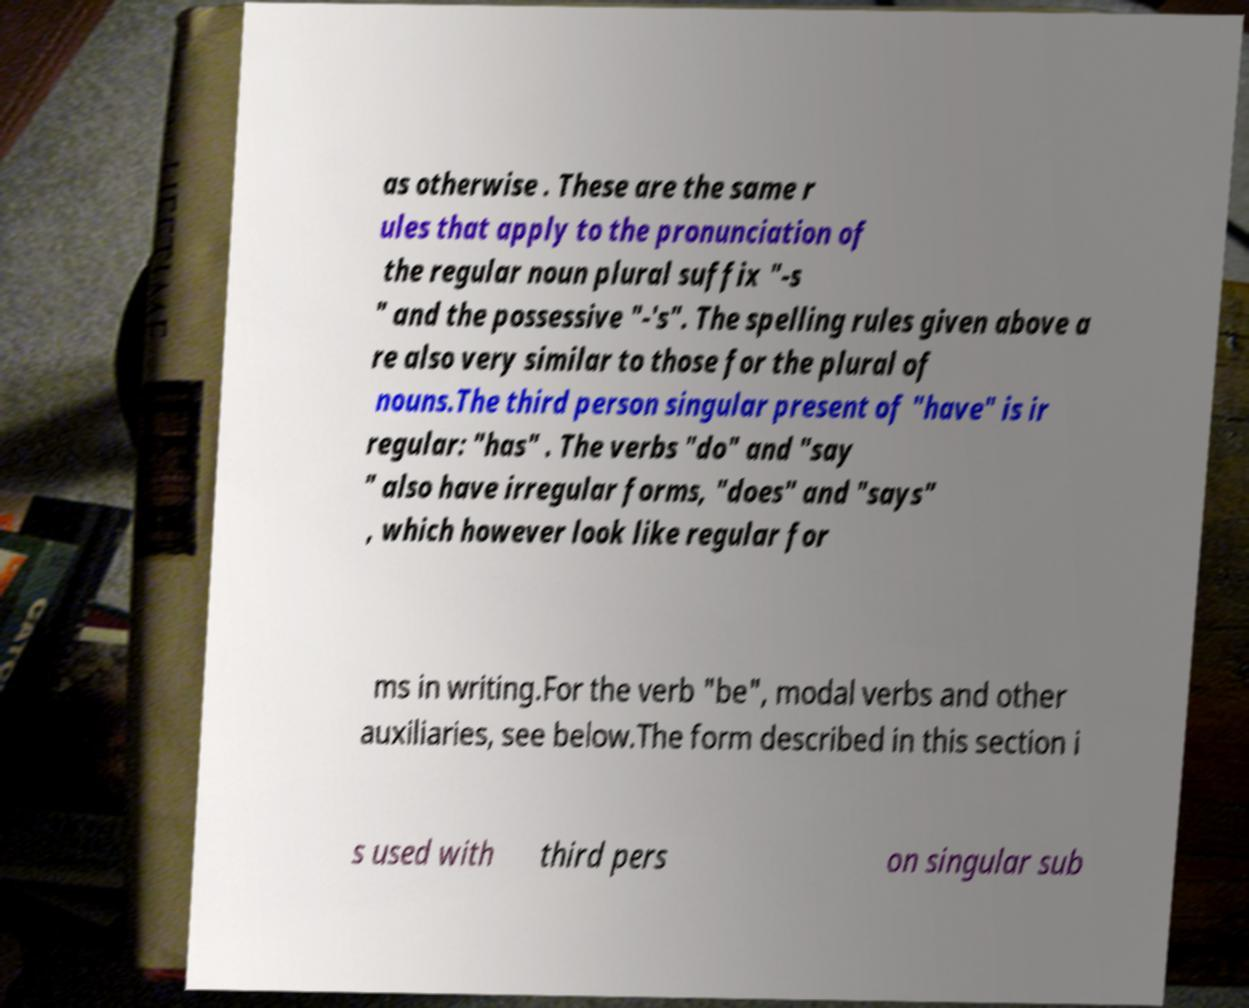Could you extract and type out the text from this image? as otherwise . These are the same r ules that apply to the pronunciation of the regular noun plural suffix "-s " and the possessive "-'s". The spelling rules given above a re also very similar to those for the plural of nouns.The third person singular present of "have" is ir regular: "has" . The verbs "do" and "say " also have irregular forms, "does" and "says" , which however look like regular for ms in writing.For the verb "be", modal verbs and other auxiliaries, see below.The form described in this section i s used with third pers on singular sub 